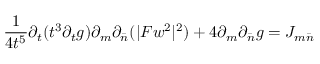Convert formula to latex. <formula><loc_0><loc_0><loc_500><loc_500>\frac { 1 } { 4 t ^ { 5 } } \partial _ { t } ( t ^ { 3 } \partial _ { t } g ) \partial _ { m } \partial _ { \bar { n } } ( | F w ^ { 2 } | ^ { 2 } ) + 4 \partial _ { m } \partial _ { \bar { n } } g = J _ { m \bar { n } }</formula> 